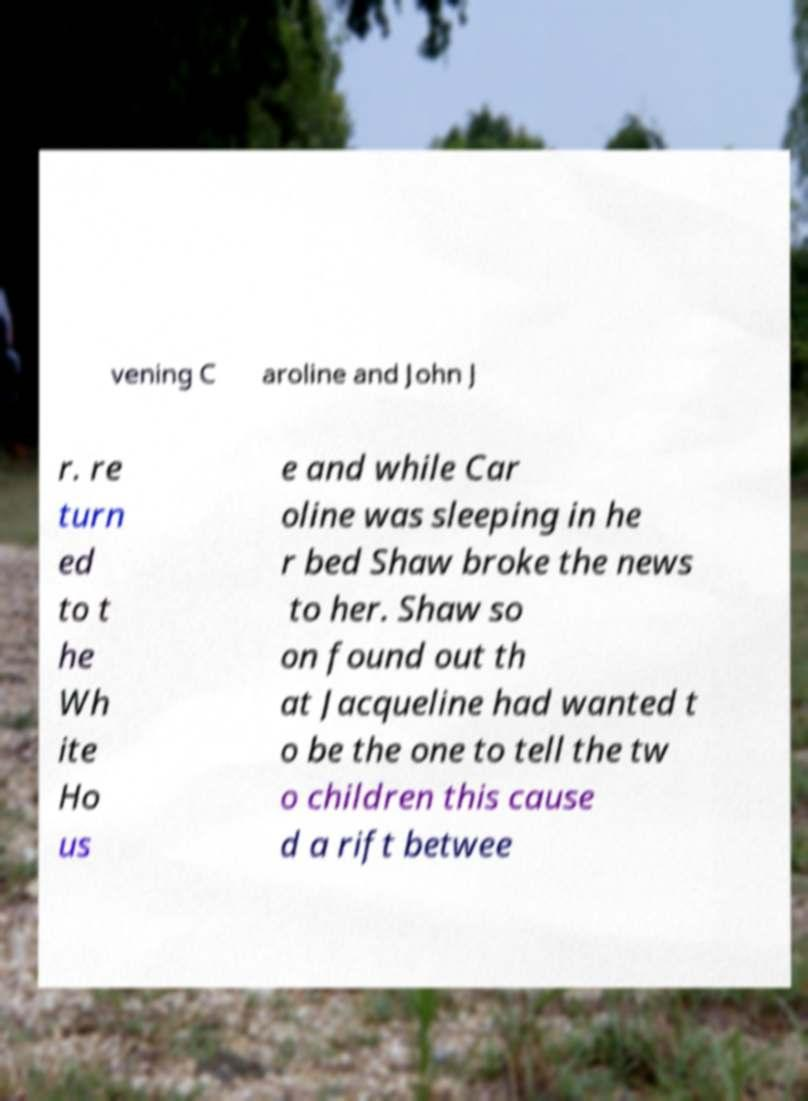Can you read and provide the text displayed in the image?This photo seems to have some interesting text. Can you extract and type it out for me? vening C aroline and John J r. re turn ed to t he Wh ite Ho us e and while Car oline was sleeping in he r bed Shaw broke the news to her. Shaw so on found out th at Jacqueline had wanted t o be the one to tell the tw o children this cause d a rift betwee 